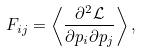Convert formula to latex. <formula><loc_0><loc_0><loc_500><loc_500>F _ { i j } = \left < \frac { \partial ^ { 2 } \mathcal { L } } { \partial p _ { i } \partial p _ { j } } \right > ,</formula> 